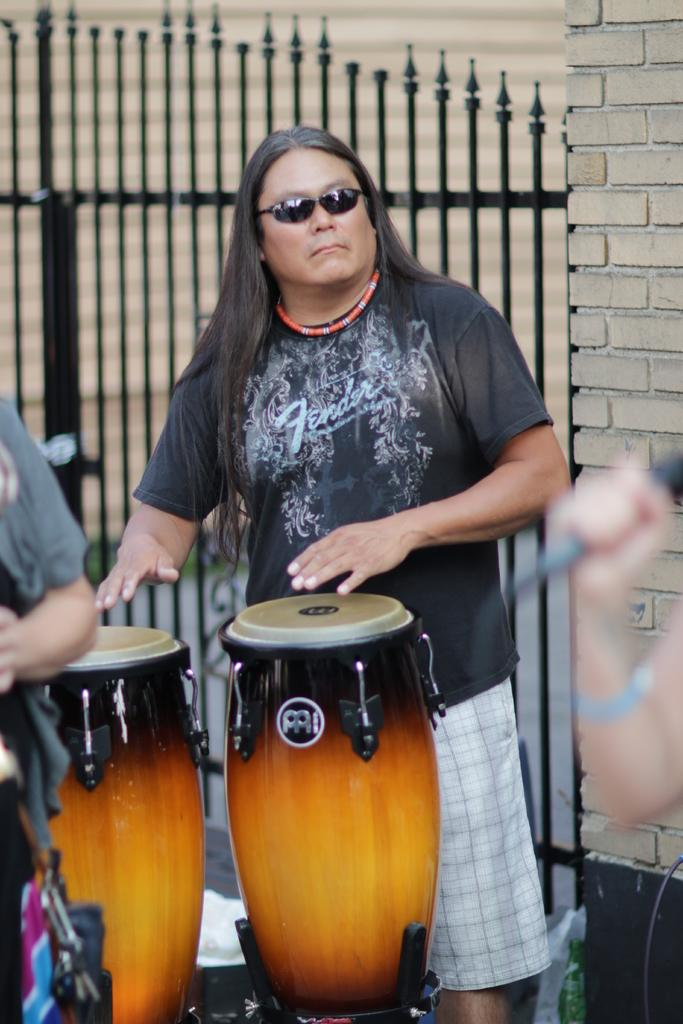What is the person in the image doing? The person is playing drums in the image. How is the person positioned in relation to the drums? The person is standing in front of the drums. What can be seen in the background of the image? There is a gate and a wall in the background of the image. What type of cake is being served at the hour depicted in the image? There is no cake or indication of time in the image; it features a person playing drums with a gate and wall in the background. 